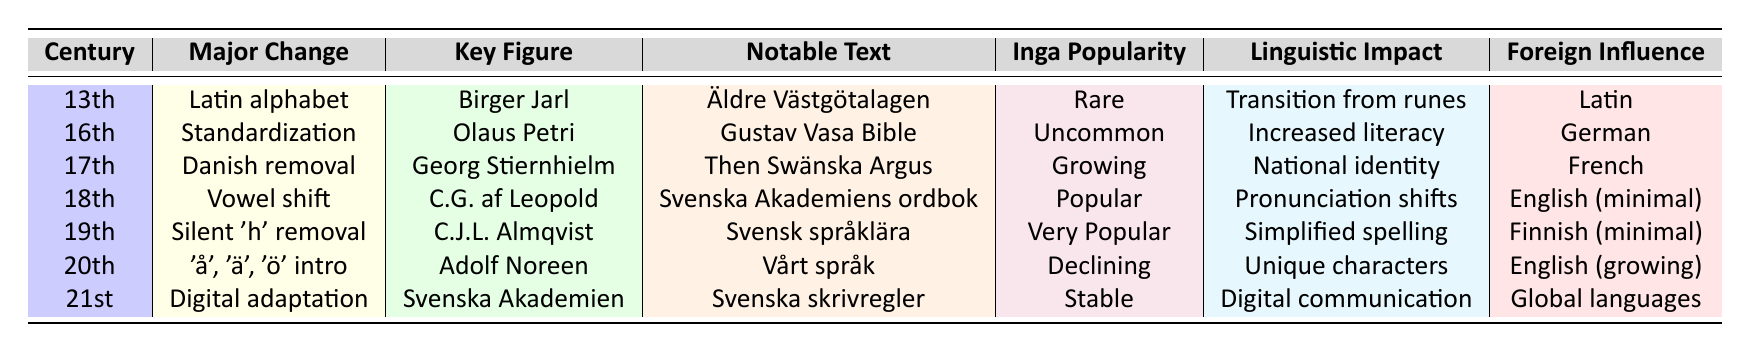What major orthographic change occurred in the 19th century? In the 19th century, the major orthographic change was the removal of silent 'h'.
Answer: Removal of silent 'h' Who was the key figure associated with the introduction of unique Swedish characters in the 20th century? The key figure associated with this change was Adolf Noreen.
Answer: Adolf Noreen What notable text is linked to the linguistic impact of increased literacy in the 16th century? The notable text associated with increased literacy in the 16th century is the Gustav Vasa Bible.
Answer: Gustav Vasa Bible Is the popularity of the name Inga growing or declining in the 20th century? In the 20th century, the popularity of the name Inga is declining.
Answer: Declining Which century saw the transition from runes to the Latin alphabet? The transition from runes to the Latin alphabet occurred in the 13th century.
Answer: 13th century What was the key figure in the 17th century focused on eliminating Danish influence? The key figure was Georg Stiernhielm.
Answer: Georg Stiernhielm In which century did Svenska Akademiens ordbok become a notable text? Svenska Akademiens ordbok became a notable text in the 18th century.
Answer: 18th century Which major change occurred in the 21st century related to foreign influence? The major change in the 21st century was digital adaptation, influenced by global languages.
Answer: Digital adaptation What can be inferred about the Inga name's popularity over the 13th to 21st centuries? The popularity of the name Inga started as rare, grew to very popular in the 19th century, and then became stable in the 21st century.
Answer: From rare to stable Which century had a notable text associated with the Vowel shift linguistically? The 18th century had a notable text associated with the Vowel shift.
Answer: 18th century What was the foreign influence on Swedish orthography in the 20th century? The foreign influence in the 20th century was English, which was growing.
Answer: English (growing) 